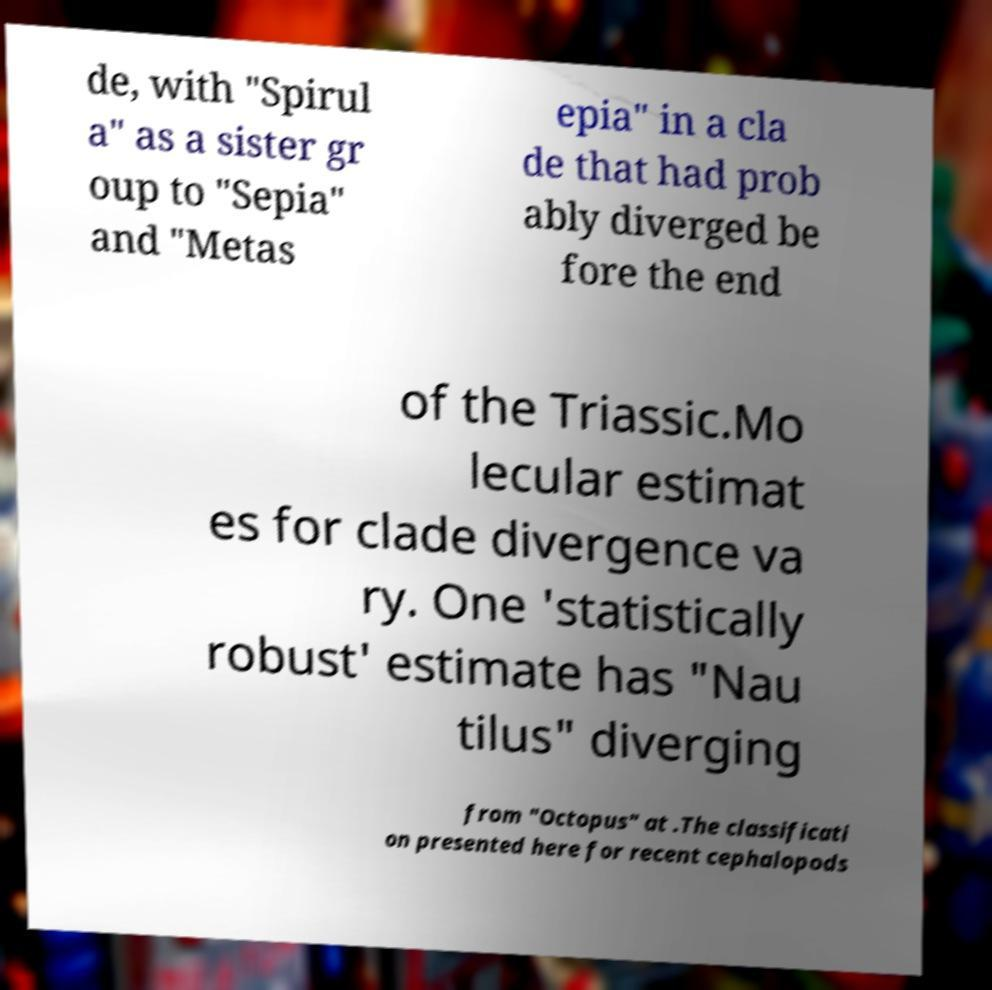Can you accurately transcribe the text from the provided image for me? de, with "Spirul a" as a sister gr oup to "Sepia" and "Metas epia" in a cla de that had prob ably diverged be fore the end of the Triassic.Mo lecular estimat es for clade divergence va ry. One 'statistically robust' estimate has "Nau tilus" diverging from "Octopus" at .The classificati on presented here for recent cephalopods 